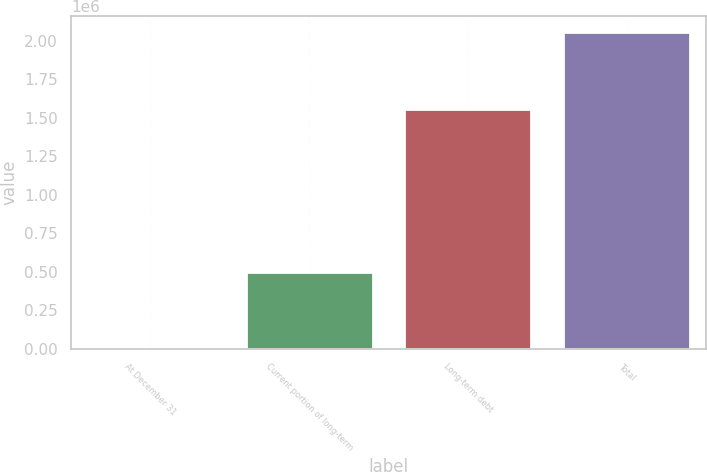<chart> <loc_0><loc_0><loc_500><loc_500><bar_chart><fcel>At December 31<fcel>Current portion of long-term<fcel>Long-term debt<fcel>Total<nl><fcel>2015<fcel>499923<fcel>1.55709e+06<fcel>2.05701e+06<nl></chart> 